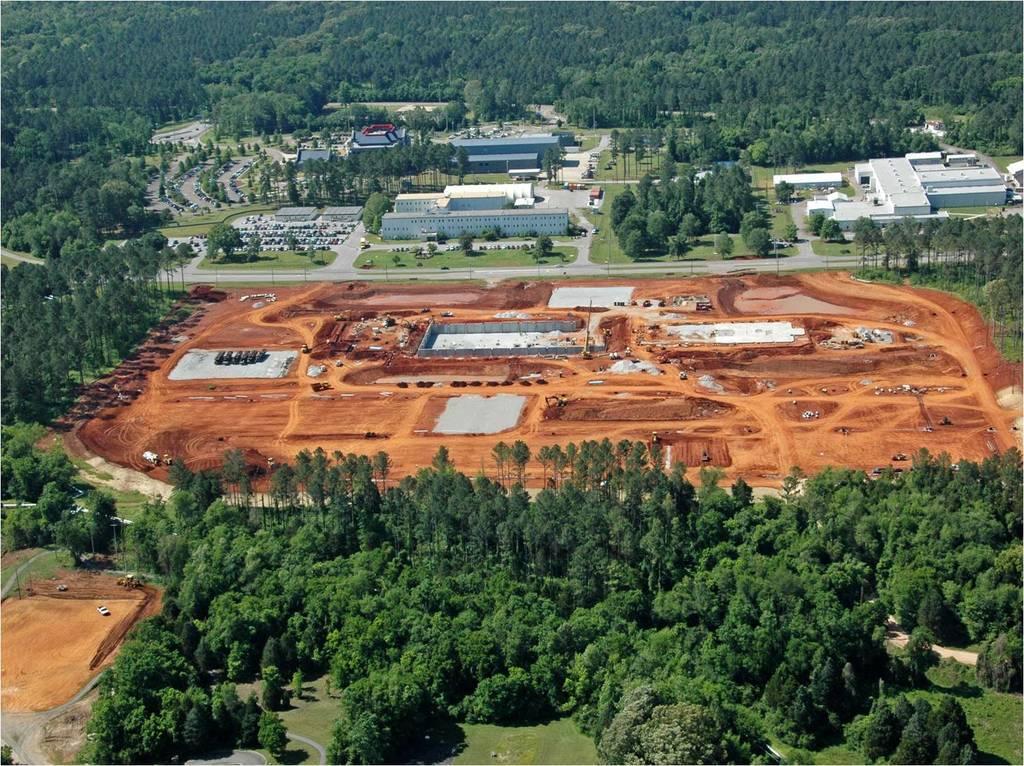Could you give a brief overview of what you see in this image? This is the aerial view of an image where we can see trees, grass, vehicles on the ground, buildings and the roads here. 